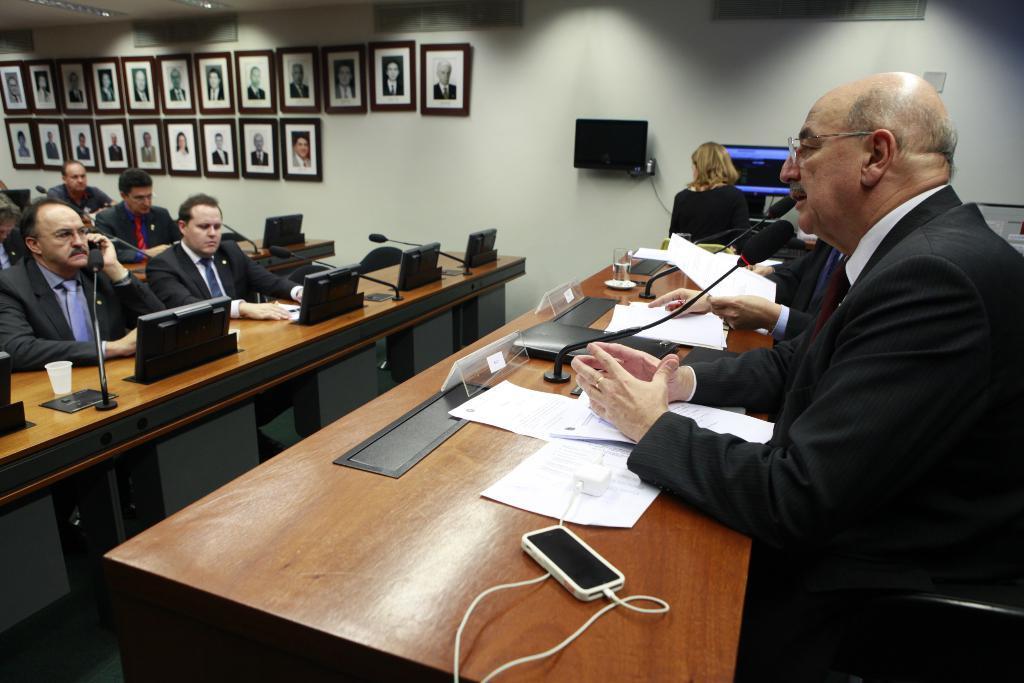How would you summarize this image in a sentence or two? This picture shows a group of people seated on the chairs and we see a man seated and speaking with the help of a microphone on the table and we see few photo frames on the wall 